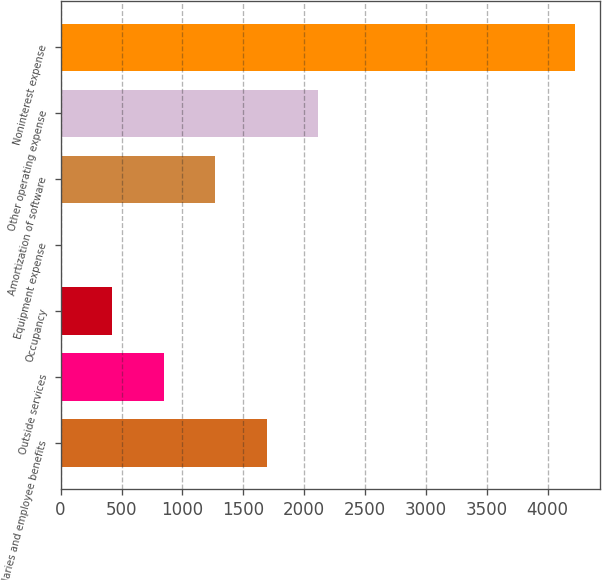<chart> <loc_0><loc_0><loc_500><loc_500><bar_chart><fcel>Salaries and employee benefits<fcel>Outside services<fcel>Occupancy<fcel>Equipment expense<fcel>Amortization of software<fcel>Other operating expense<fcel>Noninterest expense<nl><fcel>1691.2<fcel>847.6<fcel>425.8<fcel>4<fcel>1269.4<fcel>2113<fcel>4222<nl></chart> 